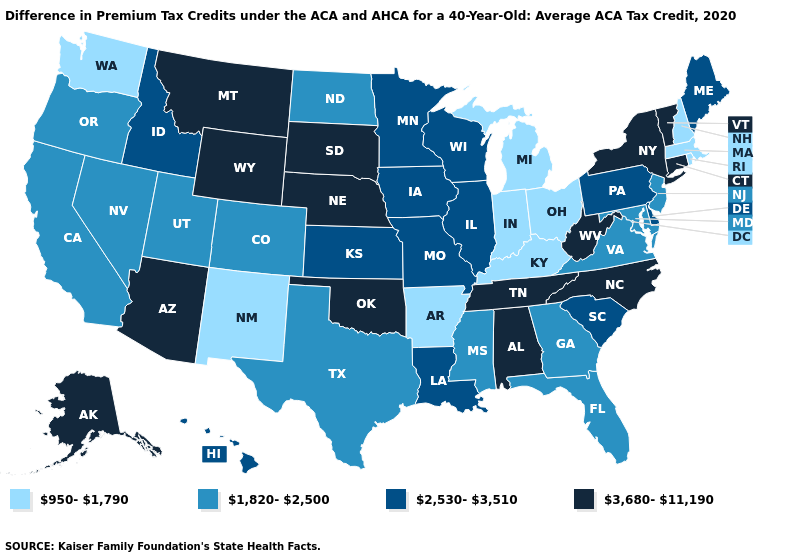Does the map have missing data?
Quick response, please. No. What is the lowest value in states that border Maryland?
Answer briefly. 1,820-2,500. What is the value of South Carolina?
Short answer required. 2,530-3,510. Does Iowa have a higher value than South Dakota?
Give a very brief answer. No. Does Rhode Island have the lowest value in the Northeast?
Answer briefly. Yes. What is the value of Arizona?
Write a very short answer. 3,680-11,190. Does Louisiana have the lowest value in the USA?
Short answer required. No. What is the highest value in the USA?
Be succinct. 3,680-11,190. Name the states that have a value in the range 3,680-11,190?
Be succinct. Alabama, Alaska, Arizona, Connecticut, Montana, Nebraska, New York, North Carolina, Oklahoma, South Dakota, Tennessee, Vermont, West Virginia, Wyoming. What is the value of Minnesota?
Be succinct. 2,530-3,510. What is the value of Kentucky?
Answer briefly. 950-1,790. Name the states that have a value in the range 2,530-3,510?
Short answer required. Delaware, Hawaii, Idaho, Illinois, Iowa, Kansas, Louisiana, Maine, Minnesota, Missouri, Pennsylvania, South Carolina, Wisconsin. What is the lowest value in the USA?
Answer briefly. 950-1,790. What is the highest value in states that border Florida?
Short answer required. 3,680-11,190. What is the highest value in the USA?
Short answer required. 3,680-11,190. 